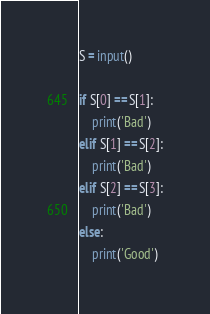<code> <loc_0><loc_0><loc_500><loc_500><_Python_>S = input()

if S[0] == S[1]:
    print('Bad')
elif S[1] == S[2]:
    print('Bad')
elif S[2] == S[3]:
    print('Bad')
else:
    print('Good')</code> 